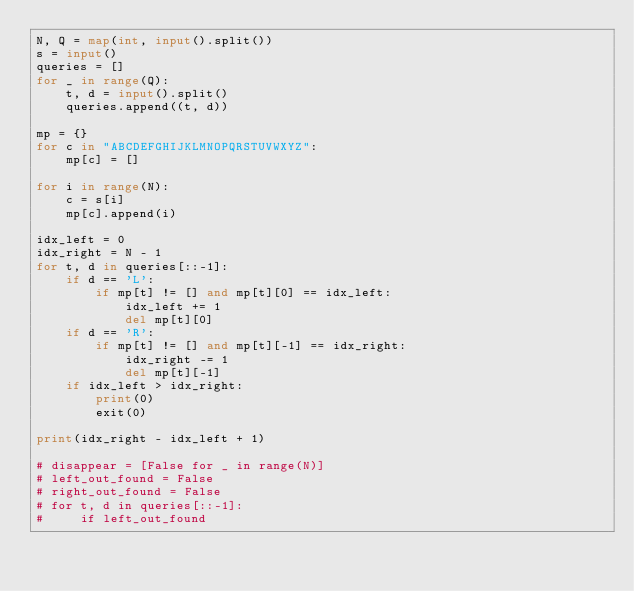<code> <loc_0><loc_0><loc_500><loc_500><_Python_>N, Q = map(int, input().split())
s = input()
queries = []
for _ in range(Q):
    t, d = input().split()
    queries.append((t, d))

mp = {}
for c in "ABCDEFGHIJKLMNOPQRSTUVWXYZ":
    mp[c] = []

for i in range(N):
    c = s[i]
    mp[c].append(i)

idx_left = 0
idx_right = N - 1
for t, d in queries[::-1]:
    if d == 'L':
        if mp[t] != [] and mp[t][0] == idx_left:
            idx_left += 1
            del mp[t][0]
    if d == 'R':
        if mp[t] != [] and mp[t][-1] == idx_right:
            idx_right -= 1
            del mp[t][-1]
    if idx_left > idx_right:
        print(0)
        exit(0)

print(idx_right - idx_left + 1)

# disappear = [False for _ in range(N)]
# left_out_found = False
# right_out_found = False
# for t, d in queries[::-1]:
#     if left_out_found</code> 